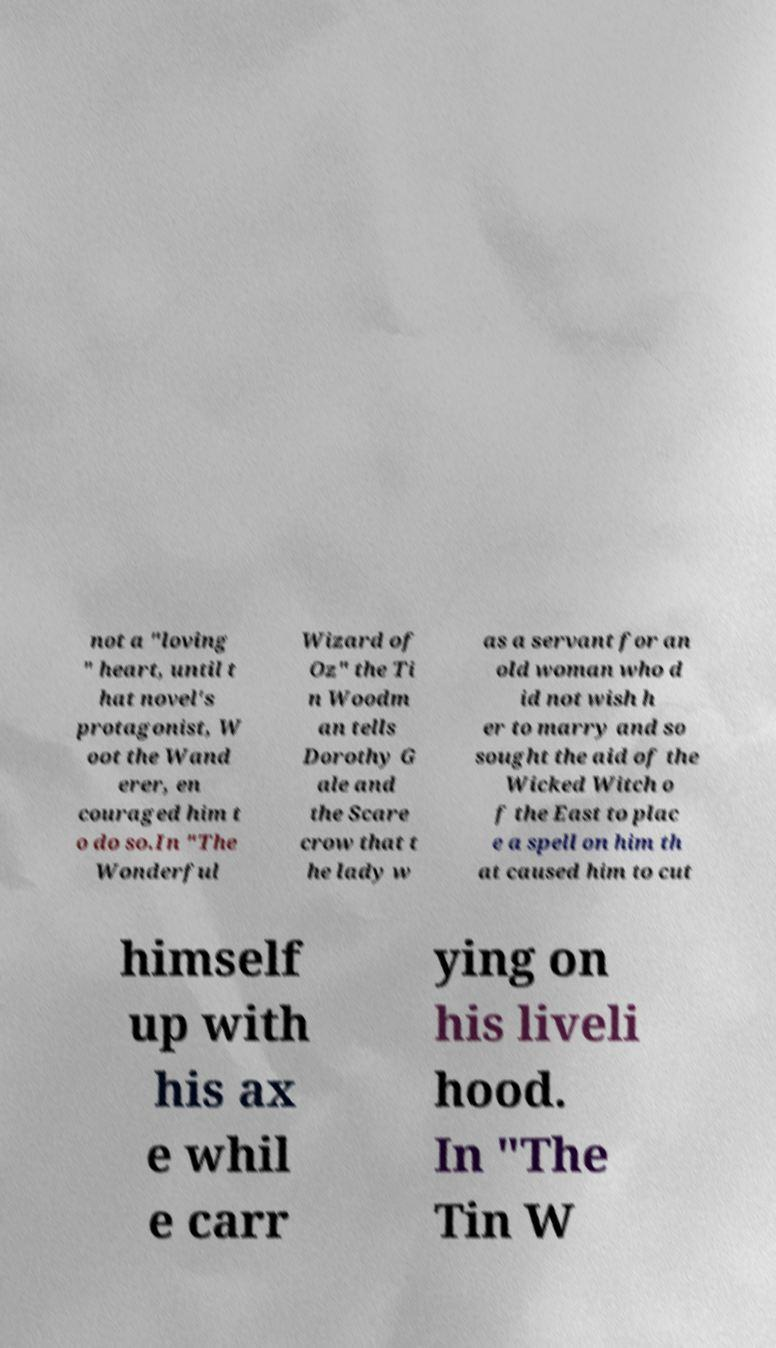Can you accurately transcribe the text from the provided image for me? not a "loving " heart, until t hat novel's protagonist, W oot the Wand erer, en couraged him t o do so.In "The Wonderful Wizard of Oz" the Ti n Woodm an tells Dorothy G ale and the Scare crow that t he lady w as a servant for an old woman who d id not wish h er to marry and so sought the aid of the Wicked Witch o f the East to plac e a spell on him th at caused him to cut himself up with his ax e whil e carr ying on his liveli hood. In "The Tin W 